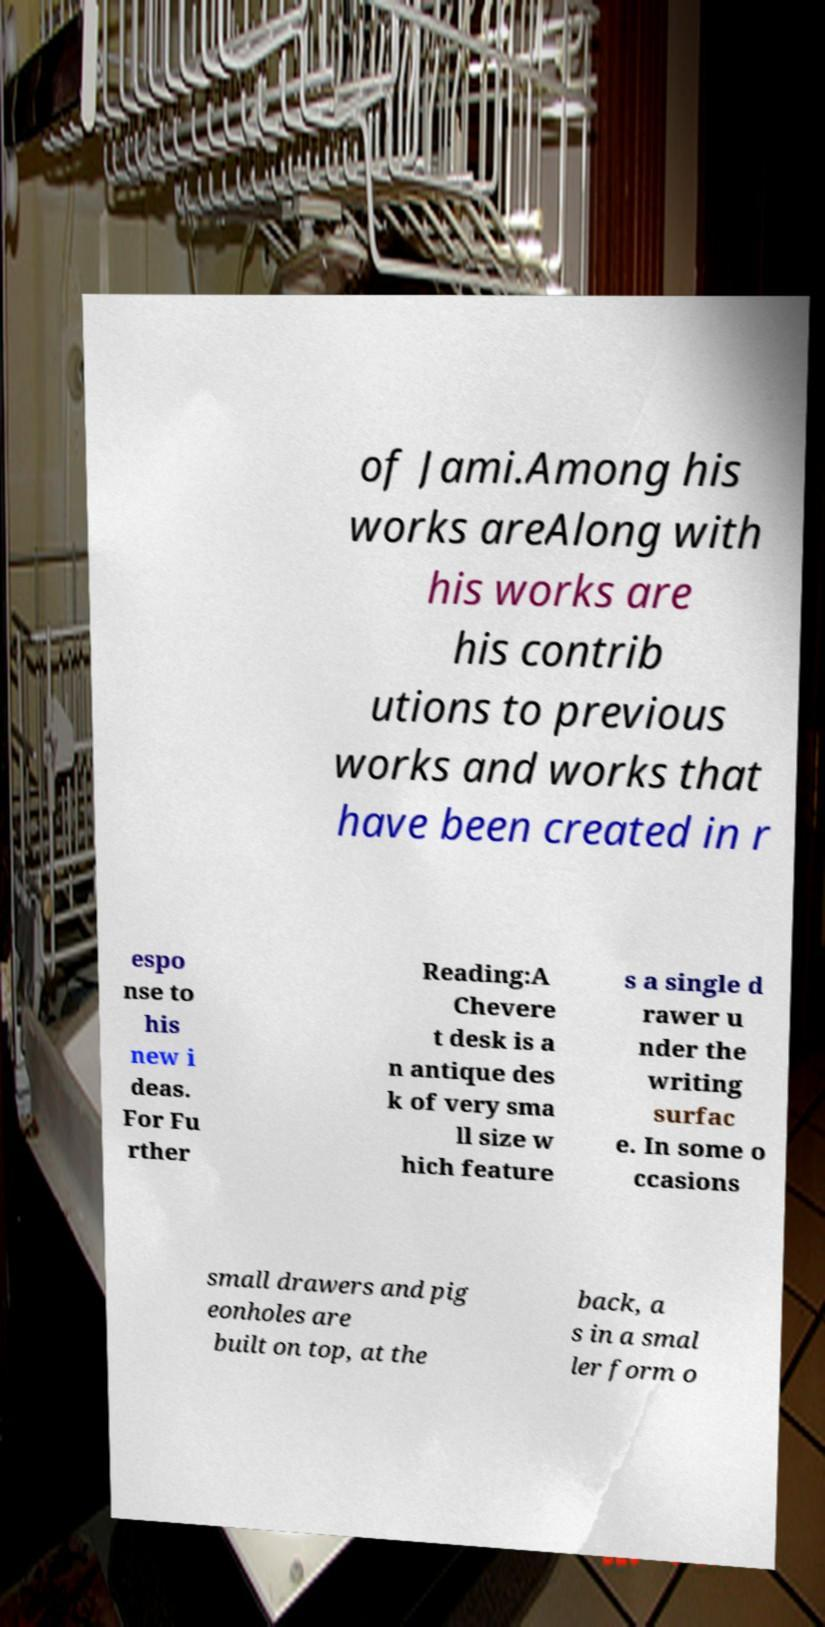Can you read and provide the text displayed in the image?This photo seems to have some interesting text. Can you extract and type it out for me? of Jami.Among his works areAlong with his works are his contrib utions to previous works and works that have been created in r espo nse to his new i deas. For Fu rther Reading:A Chevere t desk is a n antique des k of very sma ll size w hich feature s a single d rawer u nder the writing surfac e. In some o ccasions small drawers and pig eonholes are built on top, at the back, a s in a smal ler form o 